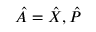Convert formula to latex. <formula><loc_0><loc_0><loc_500><loc_500>\hat { A } = \hat { X } , \hat { P }</formula> 